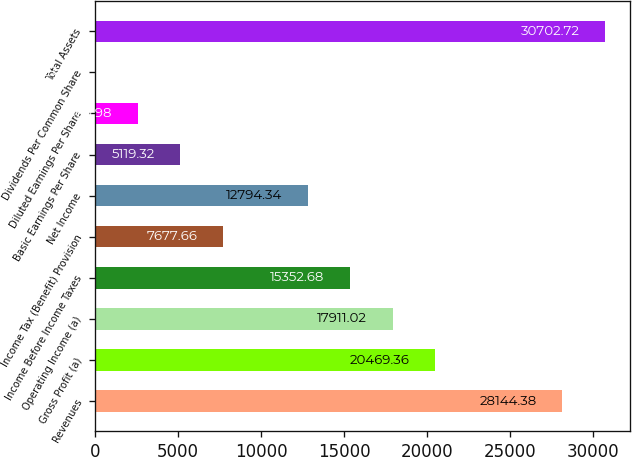Convert chart to OTSL. <chart><loc_0><loc_0><loc_500><loc_500><bar_chart><fcel>Revenues<fcel>Gross Profit (a)<fcel>Operating Income (a)<fcel>Income Before Income Taxes<fcel>Income Tax (Benefit) Provision<fcel>Net Income<fcel>Basic Earnings Per Share<fcel>Diluted Earnings Per Share<fcel>Dividends Per Common Share<fcel>Total Assets<nl><fcel>28144.4<fcel>20469.4<fcel>17911<fcel>15352.7<fcel>7677.66<fcel>12794.3<fcel>5119.32<fcel>2560.98<fcel>2.64<fcel>30702.7<nl></chart> 